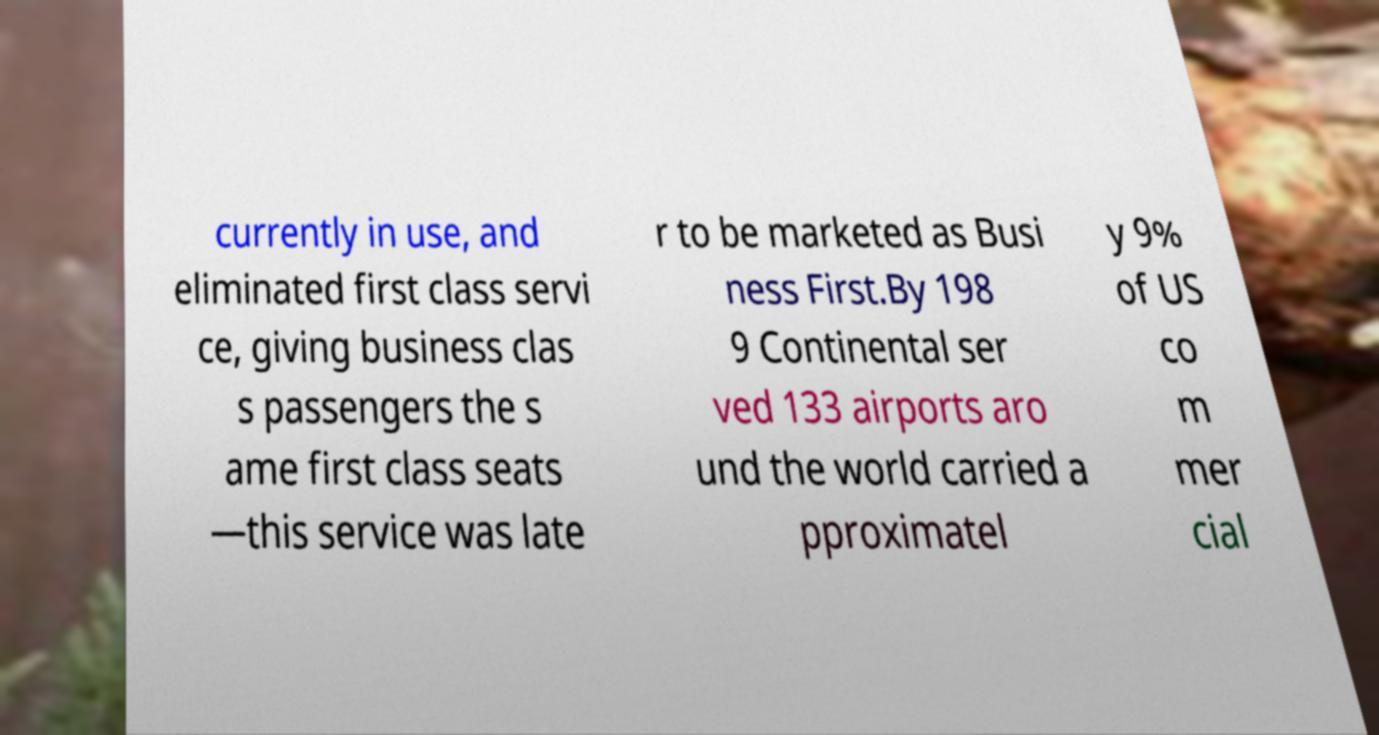For documentation purposes, I need the text within this image transcribed. Could you provide that? currently in use, and eliminated first class servi ce, giving business clas s passengers the s ame first class seats —this service was late r to be marketed as Busi ness First.By 198 9 Continental ser ved 133 airports aro und the world carried a pproximatel y 9% of US co m mer cial 